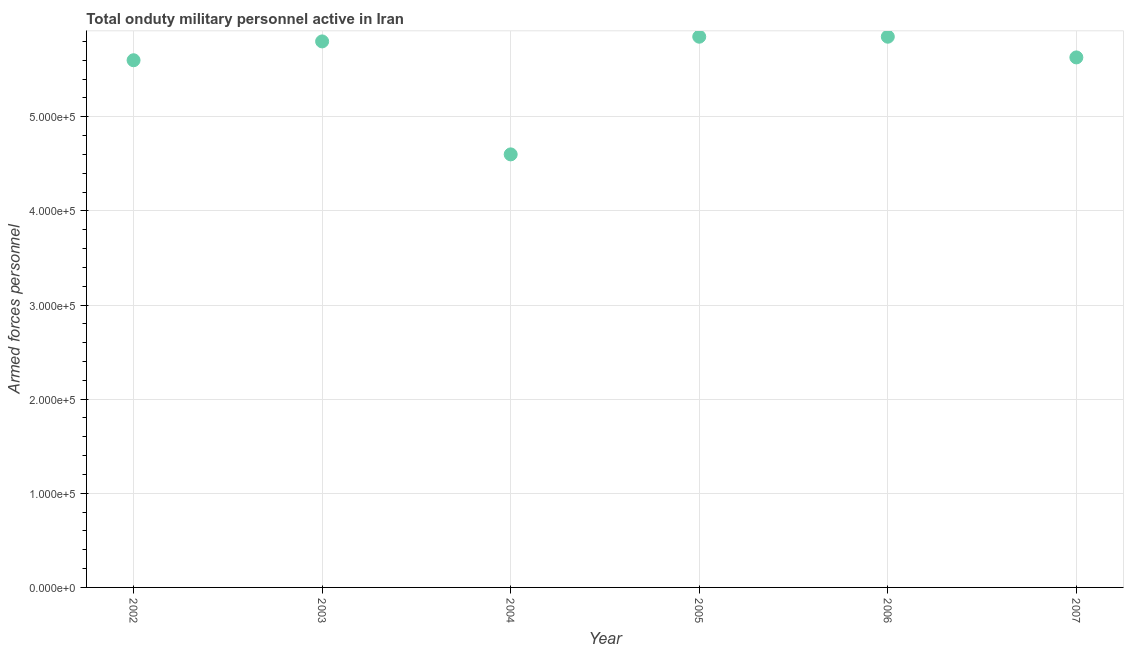What is the number of armed forces personnel in 2004?
Your answer should be compact. 4.60e+05. Across all years, what is the maximum number of armed forces personnel?
Your response must be concise. 5.85e+05. Across all years, what is the minimum number of armed forces personnel?
Make the answer very short. 4.60e+05. In which year was the number of armed forces personnel minimum?
Offer a terse response. 2004. What is the sum of the number of armed forces personnel?
Keep it short and to the point. 3.33e+06. What is the difference between the number of armed forces personnel in 2004 and 2005?
Offer a very short reply. -1.25e+05. What is the average number of armed forces personnel per year?
Keep it short and to the point. 5.56e+05. What is the median number of armed forces personnel?
Keep it short and to the point. 5.72e+05. In how many years, is the number of armed forces personnel greater than 240000 ?
Keep it short and to the point. 6. Do a majority of the years between 2007 and 2004 (inclusive) have number of armed forces personnel greater than 120000 ?
Your response must be concise. Yes. What is the ratio of the number of armed forces personnel in 2003 to that in 2006?
Offer a terse response. 0.99. Is the difference between the number of armed forces personnel in 2002 and 2003 greater than the difference between any two years?
Your response must be concise. No. What is the difference between the highest and the second highest number of armed forces personnel?
Your response must be concise. 0. Is the sum of the number of armed forces personnel in 2002 and 2005 greater than the maximum number of armed forces personnel across all years?
Your answer should be very brief. Yes. What is the difference between the highest and the lowest number of armed forces personnel?
Your answer should be very brief. 1.25e+05. In how many years, is the number of armed forces personnel greater than the average number of armed forces personnel taken over all years?
Provide a short and direct response. 5. Does the number of armed forces personnel monotonically increase over the years?
Keep it short and to the point. No. How many dotlines are there?
Make the answer very short. 1. What is the difference between two consecutive major ticks on the Y-axis?
Ensure brevity in your answer.  1.00e+05. Are the values on the major ticks of Y-axis written in scientific E-notation?
Provide a short and direct response. Yes. Does the graph contain grids?
Ensure brevity in your answer.  Yes. What is the title of the graph?
Your answer should be very brief. Total onduty military personnel active in Iran. What is the label or title of the X-axis?
Your response must be concise. Year. What is the label or title of the Y-axis?
Your response must be concise. Armed forces personnel. What is the Armed forces personnel in 2002?
Provide a short and direct response. 5.60e+05. What is the Armed forces personnel in 2003?
Offer a terse response. 5.80e+05. What is the Armed forces personnel in 2004?
Your answer should be compact. 4.60e+05. What is the Armed forces personnel in 2005?
Give a very brief answer. 5.85e+05. What is the Armed forces personnel in 2006?
Your response must be concise. 5.85e+05. What is the Armed forces personnel in 2007?
Provide a succinct answer. 5.63e+05. What is the difference between the Armed forces personnel in 2002 and 2004?
Offer a very short reply. 1.00e+05. What is the difference between the Armed forces personnel in 2002 and 2005?
Your answer should be compact. -2.50e+04. What is the difference between the Armed forces personnel in 2002 and 2006?
Offer a terse response. -2.50e+04. What is the difference between the Armed forces personnel in 2002 and 2007?
Make the answer very short. -3000. What is the difference between the Armed forces personnel in 2003 and 2005?
Keep it short and to the point. -5000. What is the difference between the Armed forces personnel in 2003 and 2006?
Give a very brief answer. -5000. What is the difference between the Armed forces personnel in 2003 and 2007?
Your answer should be very brief. 1.70e+04. What is the difference between the Armed forces personnel in 2004 and 2005?
Provide a succinct answer. -1.25e+05. What is the difference between the Armed forces personnel in 2004 and 2006?
Keep it short and to the point. -1.25e+05. What is the difference between the Armed forces personnel in 2004 and 2007?
Your response must be concise. -1.03e+05. What is the difference between the Armed forces personnel in 2005 and 2006?
Your response must be concise. 0. What is the difference between the Armed forces personnel in 2005 and 2007?
Ensure brevity in your answer.  2.20e+04. What is the difference between the Armed forces personnel in 2006 and 2007?
Your answer should be very brief. 2.20e+04. What is the ratio of the Armed forces personnel in 2002 to that in 2003?
Your answer should be very brief. 0.97. What is the ratio of the Armed forces personnel in 2002 to that in 2004?
Keep it short and to the point. 1.22. What is the ratio of the Armed forces personnel in 2002 to that in 2007?
Provide a succinct answer. 0.99. What is the ratio of the Armed forces personnel in 2003 to that in 2004?
Provide a short and direct response. 1.26. What is the ratio of the Armed forces personnel in 2004 to that in 2005?
Your answer should be compact. 0.79. What is the ratio of the Armed forces personnel in 2004 to that in 2006?
Ensure brevity in your answer.  0.79. What is the ratio of the Armed forces personnel in 2004 to that in 2007?
Ensure brevity in your answer.  0.82. What is the ratio of the Armed forces personnel in 2005 to that in 2006?
Ensure brevity in your answer.  1. What is the ratio of the Armed forces personnel in 2005 to that in 2007?
Your answer should be very brief. 1.04. What is the ratio of the Armed forces personnel in 2006 to that in 2007?
Offer a very short reply. 1.04. 